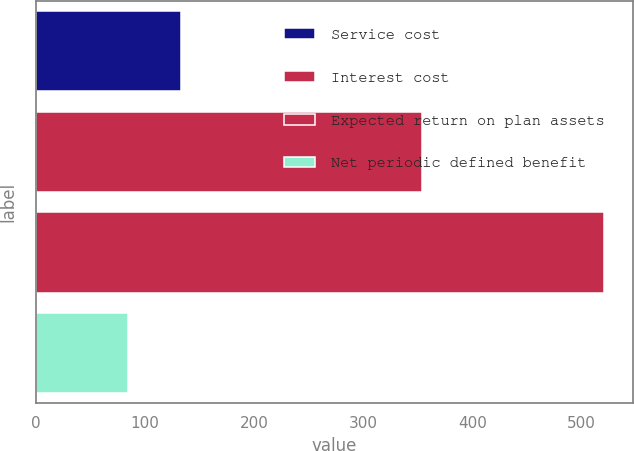Convert chart to OTSL. <chart><loc_0><loc_0><loc_500><loc_500><bar_chart><fcel>Service cost<fcel>Interest cost<fcel>Expected return on plan assets<fcel>Net periodic defined benefit<nl><fcel>133<fcel>354<fcel>521<fcel>84.5<nl></chart> 